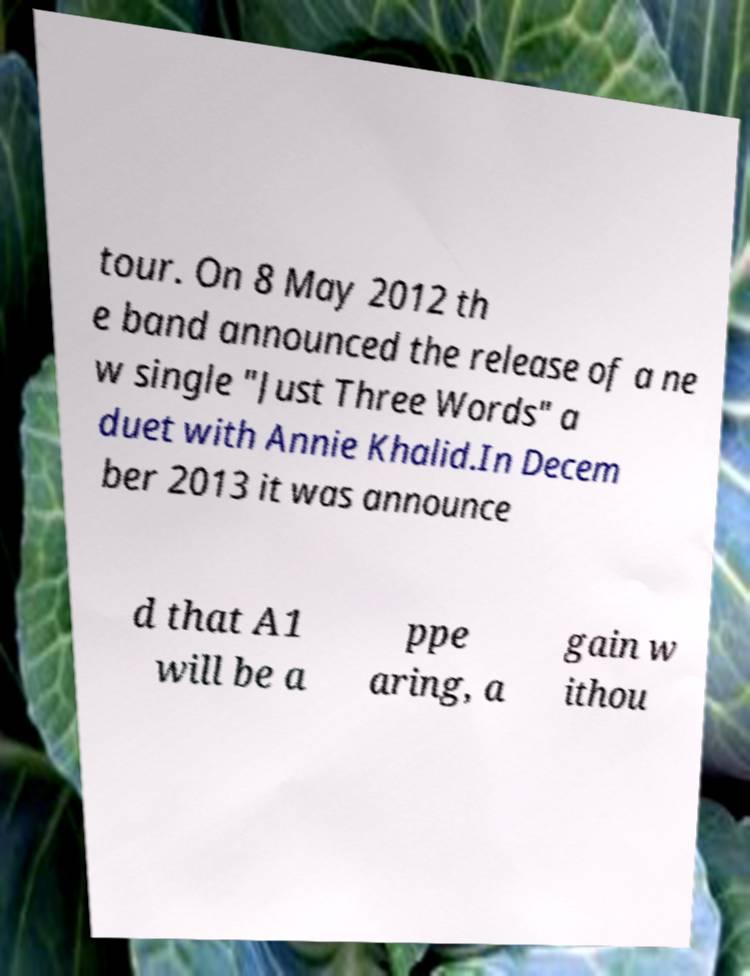What messages or text are displayed in this image? I need them in a readable, typed format. tour. On 8 May 2012 th e band announced the release of a ne w single "Just Three Words" a duet with Annie Khalid.In Decem ber 2013 it was announce d that A1 will be a ppe aring, a gain w ithou 